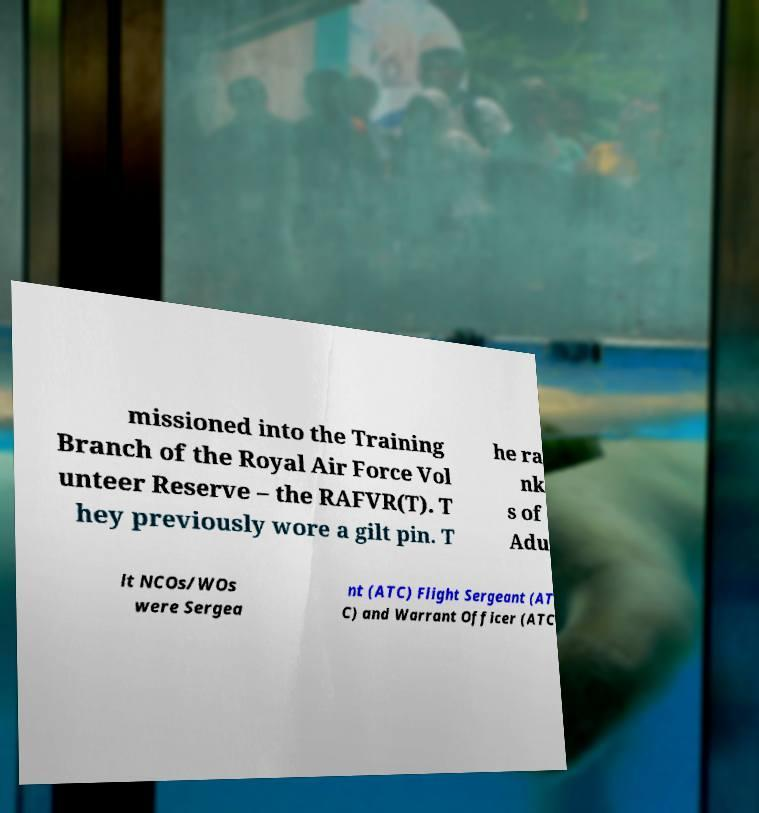Please identify and transcribe the text found in this image. missioned into the Training Branch of the Royal Air Force Vol unteer Reserve – the RAFVR(T). T hey previously wore a gilt pin. T he ra nk s of Adu lt NCOs/WOs were Sergea nt (ATC) Flight Sergeant (AT C) and Warrant Officer (ATC 